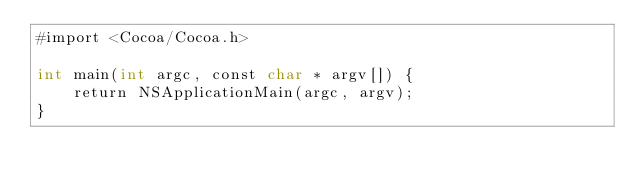<code> <loc_0><loc_0><loc_500><loc_500><_ObjectiveC_>#import <Cocoa/Cocoa.h>

int main(int argc, const char * argv[]) {
    return NSApplicationMain(argc, argv);
}
</code> 